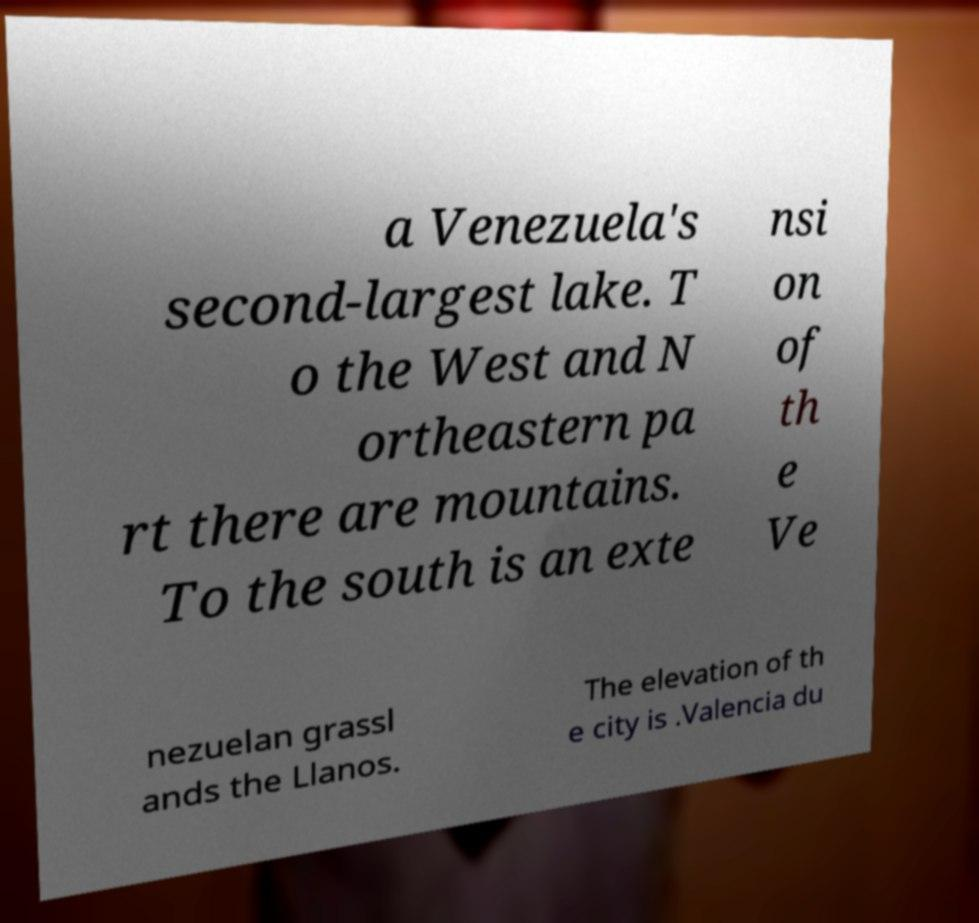Could you extract and type out the text from this image? a Venezuela's second-largest lake. T o the West and N ortheastern pa rt there are mountains. To the south is an exte nsi on of th e Ve nezuelan grassl ands the Llanos. The elevation of th e city is .Valencia du 